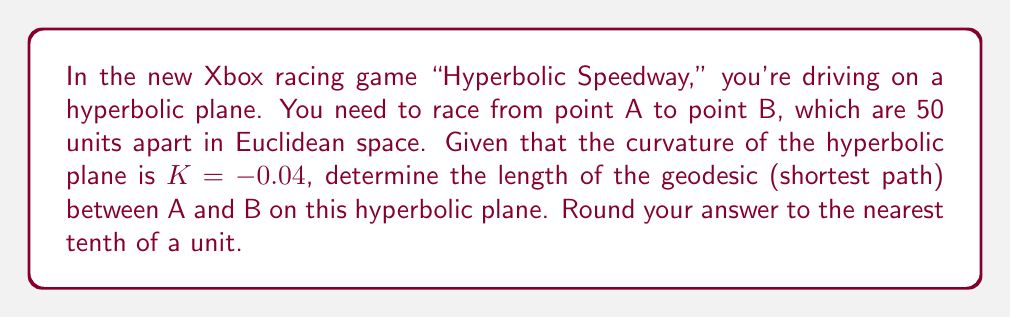Teach me how to tackle this problem. To solve this problem, we'll use the formula for the length of a geodesic in hyperbolic geometry:

1) The formula for the length of a geodesic (L) in hyperbolic geometry is:

   $$L = \frac{1}{\sqrt{|K|}} \cdot \text{arcosh}(1 + \frac{|K|d^2}{2})$$

   Where K is the curvature and d is the Euclidean distance between the points.

2) We're given:
   K = -0.04
   d = 50 units

3) Let's substitute these values into the formula:

   $$L = \frac{1}{\sqrt{|-0.04|}} \cdot \text{arcosh}(1 + \frac{|-0.04| \cdot 50^2}{2})$$

4) Simplify:
   $$L = 5 \cdot \text{arcosh}(1 + 50)$$

5) Calculate:
   $$L = 5 \cdot \text{arcosh}(51) \approx 5 \cdot 4.63 = 23.15$$

6) Rounding to the nearest tenth:
   L ≈ 23.2 units

This means that in the hyperbolic geometry of the game, the shortest path between the two points is approximately 23.2 units long, even though they're 50 units apart in Euclidean space.
Answer: 23.2 units 